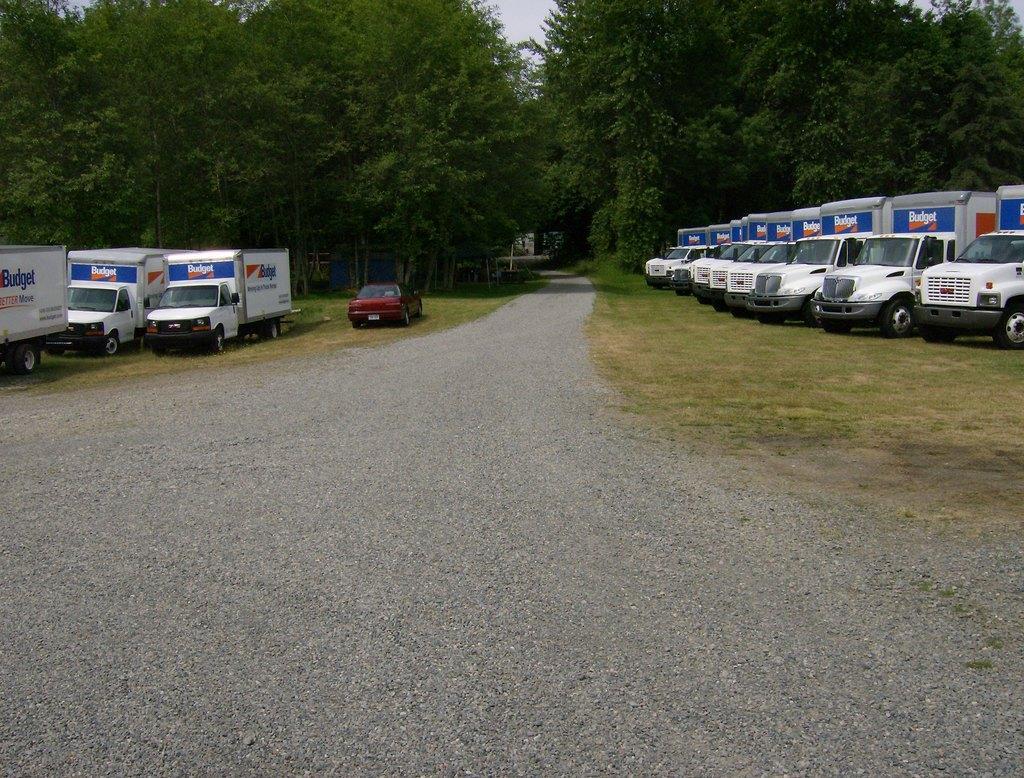Describe this image in one or two sentences. In the picture we can see a road on the both the sides of the road we can see grass surface and some trucks on both the sides and a car is also parking on the left hand side which is red in color and we can see trees on both the sides and on the top of the trees we can see a part of the sky. 